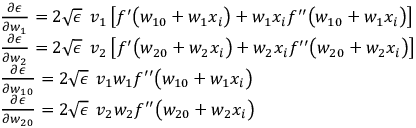<formula> <loc_0><loc_0><loc_500><loc_500>\begin{array} { r l } & { \frac { \partial \epsilon } { \partial w _ { 1 } } = 2 \sqrt { \epsilon } \, v _ { 1 } \left [ f ^ { \prime } \left ( w _ { 1 0 } + w _ { 1 } x _ { i } \right ) + w _ { 1 } x _ { i } f ^ { \prime \prime } \left ( w _ { 1 0 } + w _ { 1 } x _ { i } \right ) \right ] } \\ & { \frac { \partial \epsilon } { \partial w _ { 2 } } = 2 \sqrt { \epsilon } \, v _ { 2 } \left [ f ^ { \prime } \left ( w _ { 2 0 } + w _ { 2 } x _ { i } \right ) + w _ { 2 } x _ { i } f ^ { \prime \prime } \left ( w _ { 2 0 } + w _ { 2 } x _ { i } \right ) \right ] } \\ & { \frac { \partial \epsilon } { \partial w _ { 1 0 } } = 2 \sqrt { \epsilon } \, v _ { 1 } w _ { 1 } f ^ { \prime \prime } \left ( w _ { 1 0 } + w _ { 1 } x _ { i } \right ) } \\ & { \frac { \partial \epsilon } { \partial w _ { 2 0 } } = 2 \sqrt { \epsilon } \, v _ { 2 } w _ { 2 } f ^ { \prime \prime } \left ( w _ { 2 0 } + w _ { 2 } x _ { i } \right ) } \end{array}</formula> 